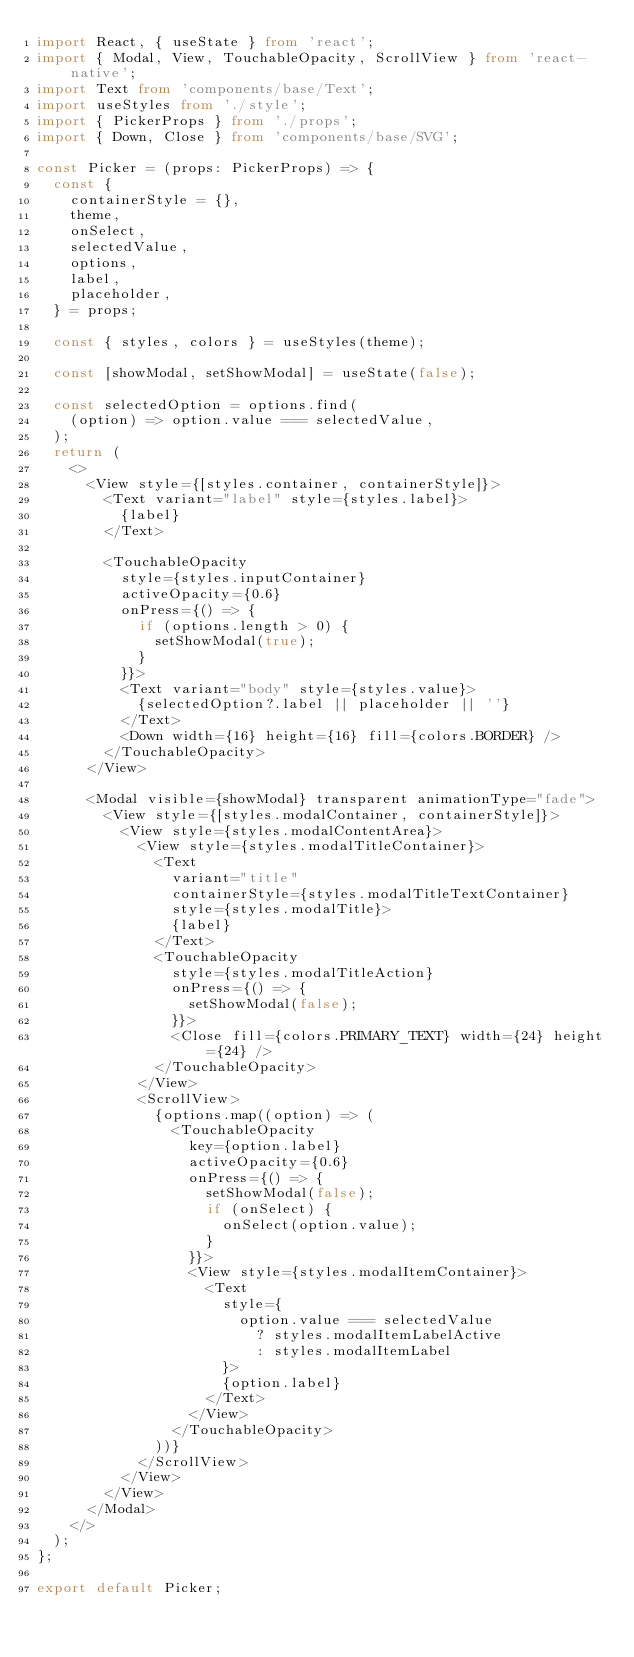<code> <loc_0><loc_0><loc_500><loc_500><_TypeScript_>import React, { useState } from 'react';
import { Modal, View, TouchableOpacity, ScrollView } from 'react-native';
import Text from 'components/base/Text';
import useStyles from './style';
import { PickerProps } from './props';
import { Down, Close } from 'components/base/SVG';

const Picker = (props: PickerProps) => {
  const {
    containerStyle = {},
    theme,
    onSelect,
    selectedValue,
    options,
    label,
    placeholder,
  } = props;

  const { styles, colors } = useStyles(theme);

  const [showModal, setShowModal] = useState(false);

  const selectedOption = options.find(
    (option) => option.value === selectedValue,
  );
  return (
    <>
      <View style={[styles.container, containerStyle]}>
        <Text variant="label" style={styles.label}>
          {label}
        </Text>

        <TouchableOpacity
          style={styles.inputContainer}
          activeOpacity={0.6}
          onPress={() => {
            if (options.length > 0) {
              setShowModal(true);
            }
          }}>
          <Text variant="body" style={styles.value}>
            {selectedOption?.label || placeholder || ''}
          </Text>
          <Down width={16} height={16} fill={colors.BORDER} />
        </TouchableOpacity>
      </View>

      <Modal visible={showModal} transparent animationType="fade">
        <View style={[styles.modalContainer, containerStyle]}>
          <View style={styles.modalContentArea}>
            <View style={styles.modalTitleContainer}>
              <Text
                variant="title"
                containerStyle={styles.modalTitleTextContainer}
                style={styles.modalTitle}>
                {label}
              </Text>
              <TouchableOpacity
                style={styles.modalTitleAction}
                onPress={() => {
                  setShowModal(false);
                }}>
                <Close fill={colors.PRIMARY_TEXT} width={24} height={24} />
              </TouchableOpacity>
            </View>
            <ScrollView>
              {options.map((option) => (
                <TouchableOpacity
                  key={option.label}
                  activeOpacity={0.6}
                  onPress={() => {
                    setShowModal(false);
                    if (onSelect) {
                      onSelect(option.value);
                    }
                  }}>
                  <View style={styles.modalItemContainer}>
                    <Text
                      style={
                        option.value === selectedValue
                          ? styles.modalItemLabelActive
                          : styles.modalItemLabel
                      }>
                      {option.label}
                    </Text>
                  </View>
                </TouchableOpacity>
              ))}
            </ScrollView>
          </View>
        </View>
      </Modal>
    </>
  );
};

export default Picker;
</code> 